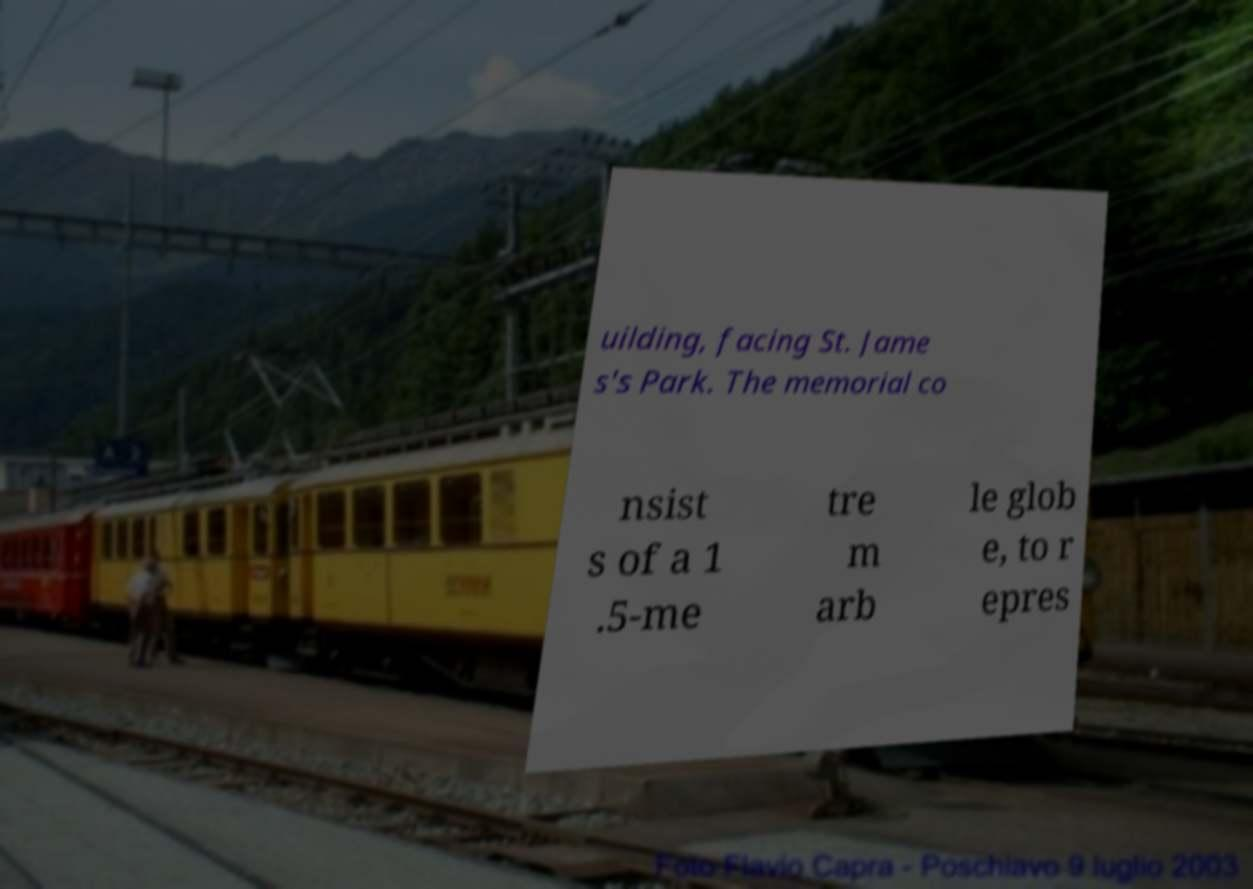Can you read and provide the text displayed in the image?This photo seems to have some interesting text. Can you extract and type it out for me? uilding, facing St. Jame s's Park. The memorial co nsist s of a 1 .5-me tre m arb le glob e, to r epres 